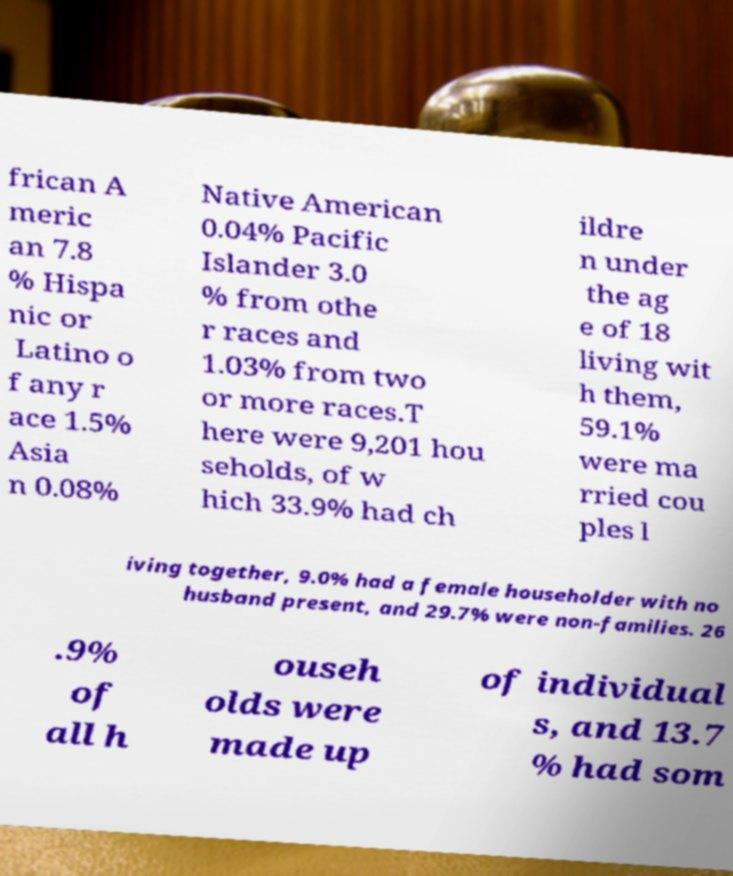For documentation purposes, I need the text within this image transcribed. Could you provide that? frican A meric an 7.8 % Hispa nic or Latino o f any r ace 1.5% Asia n 0.08% Native American 0.04% Pacific Islander 3.0 % from othe r races and 1.03% from two or more races.T here were 9,201 hou seholds, of w hich 33.9% had ch ildre n under the ag e of 18 living wit h them, 59.1% were ma rried cou ples l iving together, 9.0% had a female householder with no husband present, and 29.7% were non-families. 26 .9% of all h ouseh olds were made up of individual s, and 13.7 % had som 